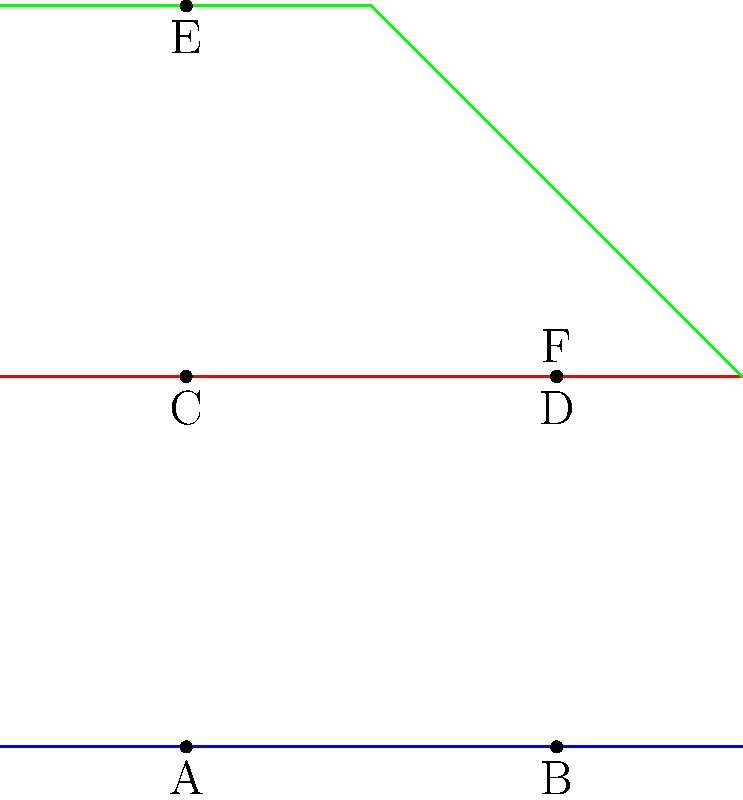In this simplified NYC subway map, which two triangles formed by the stations are congruent? To identify congruent triangles in this subway map, we need to follow these steps:

1. Identify the triangles formed by the stations:
   - Triangle ACE: formed by stations A, C, and E
   - Triangle BDF: formed by stations B, D, and F

2. Compare the sides of these triangles:
   - AC = BD (both are vertical segments of equal length)
   - AE = BF (both are diagonal segments of equal length)
   - CE = DF (both are horizontal segments of equal length)

3. Compare the angles of these triangles:
   - Angle CAE = Angle DBF (both are right angles)
   - The other two angles in each triangle are also equal due to the equal sides

4. Apply the definition of congruent triangles:
   Two triangles are congruent if they have three equal sides and three equal angles.

5. Conclusion:
   Triangle ACE is congruent to Triangle BDF because they have three equal sides and three equal angles.
Answer: ACE and BDF 